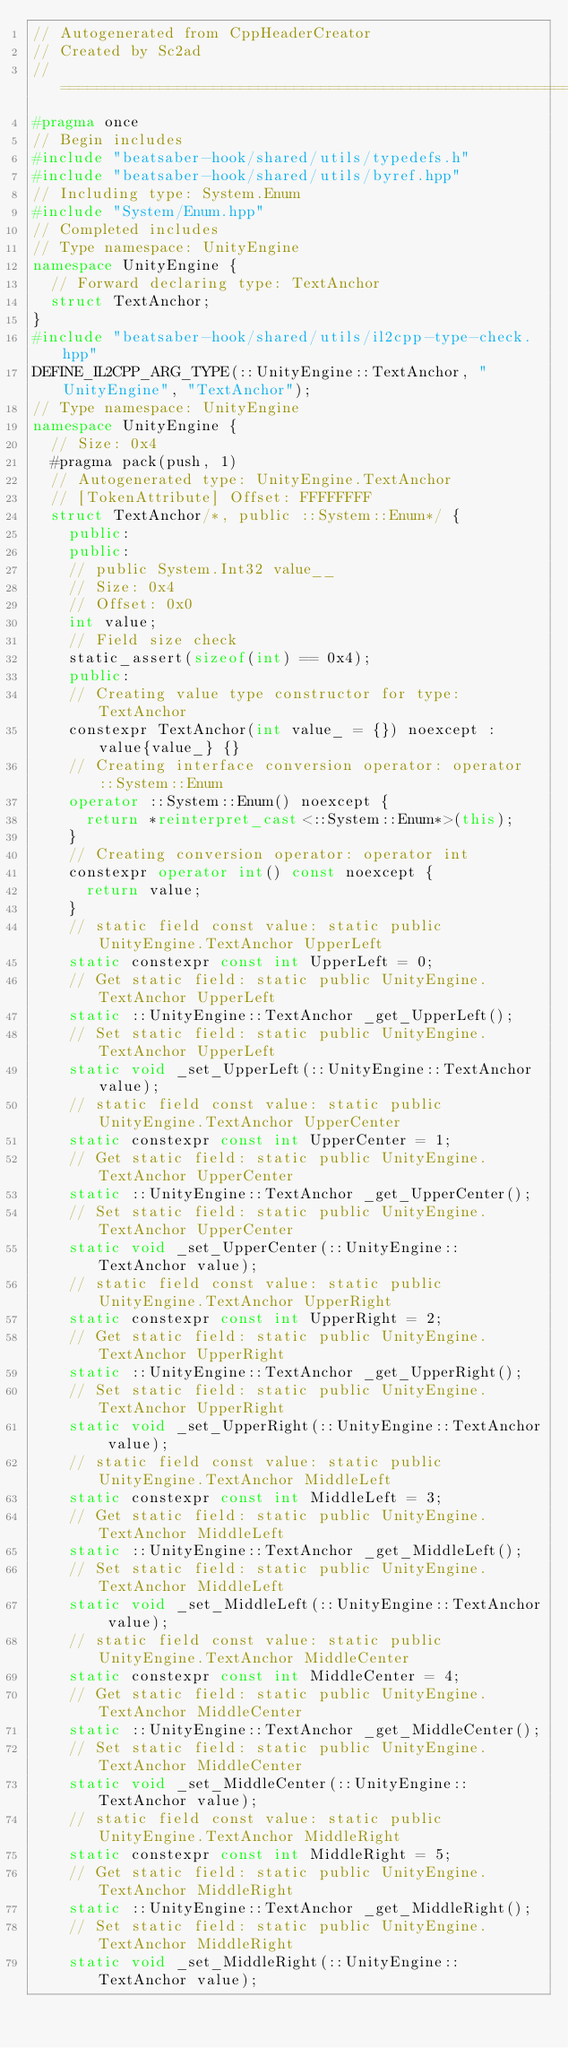Convert code to text. <code><loc_0><loc_0><loc_500><loc_500><_C++_>// Autogenerated from CppHeaderCreator
// Created by Sc2ad
// =========================================================================
#pragma once
// Begin includes
#include "beatsaber-hook/shared/utils/typedefs.h"
#include "beatsaber-hook/shared/utils/byref.hpp"
// Including type: System.Enum
#include "System/Enum.hpp"
// Completed includes
// Type namespace: UnityEngine
namespace UnityEngine {
  // Forward declaring type: TextAnchor
  struct TextAnchor;
}
#include "beatsaber-hook/shared/utils/il2cpp-type-check.hpp"
DEFINE_IL2CPP_ARG_TYPE(::UnityEngine::TextAnchor, "UnityEngine", "TextAnchor");
// Type namespace: UnityEngine
namespace UnityEngine {
  // Size: 0x4
  #pragma pack(push, 1)
  // Autogenerated type: UnityEngine.TextAnchor
  // [TokenAttribute] Offset: FFFFFFFF
  struct TextAnchor/*, public ::System::Enum*/ {
    public:
    public:
    // public System.Int32 value__
    // Size: 0x4
    // Offset: 0x0
    int value;
    // Field size check
    static_assert(sizeof(int) == 0x4);
    public:
    // Creating value type constructor for type: TextAnchor
    constexpr TextAnchor(int value_ = {}) noexcept : value{value_} {}
    // Creating interface conversion operator: operator ::System::Enum
    operator ::System::Enum() noexcept {
      return *reinterpret_cast<::System::Enum*>(this);
    }
    // Creating conversion operator: operator int
    constexpr operator int() const noexcept {
      return value;
    }
    // static field const value: static public UnityEngine.TextAnchor UpperLeft
    static constexpr const int UpperLeft = 0;
    // Get static field: static public UnityEngine.TextAnchor UpperLeft
    static ::UnityEngine::TextAnchor _get_UpperLeft();
    // Set static field: static public UnityEngine.TextAnchor UpperLeft
    static void _set_UpperLeft(::UnityEngine::TextAnchor value);
    // static field const value: static public UnityEngine.TextAnchor UpperCenter
    static constexpr const int UpperCenter = 1;
    // Get static field: static public UnityEngine.TextAnchor UpperCenter
    static ::UnityEngine::TextAnchor _get_UpperCenter();
    // Set static field: static public UnityEngine.TextAnchor UpperCenter
    static void _set_UpperCenter(::UnityEngine::TextAnchor value);
    // static field const value: static public UnityEngine.TextAnchor UpperRight
    static constexpr const int UpperRight = 2;
    // Get static field: static public UnityEngine.TextAnchor UpperRight
    static ::UnityEngine::TextAnchor _get_UpperRight();
    // Set static field: static public UnityEngine.TextAnchor UpperRight
    static void _set_UpperRight(::UnityEngine::TextAnchor value);
    // static field const value: static public UnityEngine.TextAnchor MiddleLeft
    static constexpr const int MiddleLeft = 3;
    // Get static field: static public UnityEngine.TextAnchor MiddleLeft
    static ::UnityEngine::TextAnchor _get_MiddleLeft();
    // Set static field: static public UnityEngine.TextAnchor MiddleLeft
    static void _set_MiddleLeft(::UnityEngine::TextAnchor value);
    // static field const value: static public UnityEngine.TextAnchor MiddleCenter
    static constexpr const int MiddleCenter = 4;
    // Get static field: static public UnityEngine.TextAnchor MiddleCenter
    static ::UnityEngine::TextAnchor _get_MiddleCenter();
    // Set static field: static public UnityEngine.TextAnchor MiddleCenter
    static void _set_MiddleCenter(::UnityEngine::TextAnchor value);
    // static field const value: static public UnityEngine.TextAnchor MiddleRight
    static constexpr const int MiddleRight = 5;
    // Get static field: static public UnityEngine.TextAnchor MiddleRight
    static ::UnityEngine::TextAnchor _get_MiddleRight();
    // Set static field: static public UnityEngine.TextAnchor MiddleRight
    static void _set_MiddleRight(::UnityEngine::TextAnchor value);</code> 